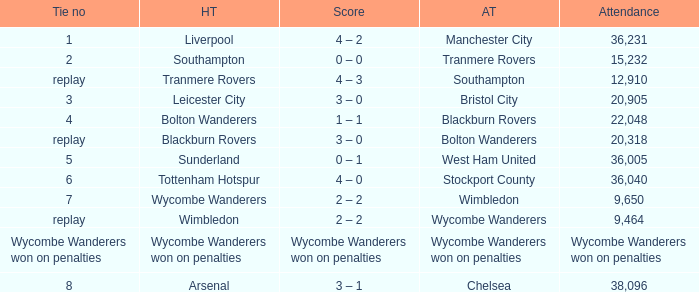What was the score for the game where the home team was Wycombe Wanderers? 2 – 2. 